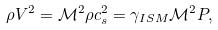<formula> <loc_0><loc_0><loc_500><loc_500>\rho V ^ { 2 } = \mathcal { M } ^ { 2 } \rho c _ { s } ^ { 2 } = \gamma _ { I S M } \mathcal { M } ^ { 2 } P ,</formula> 